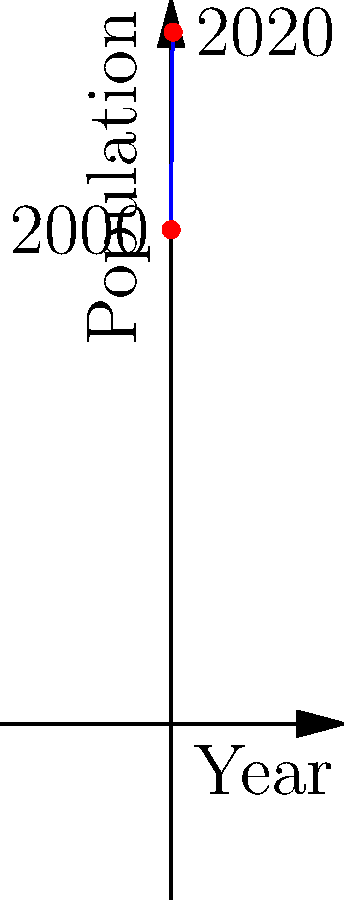The line graph shows the estimated population growth of Blahodatne from 2000 to 2020. Based on the trend shown, in which year did Blahodatne's population likely reach its peak? To determine the year when Blahodatne's population reached its peak, we need to analyze the graph:

1. The graph shows a curved line, indicating non-linear growth.
2. The population increases from 2000, reaches a maximum point, and then starts to decrease.
3. To find the year of peak population, we need to identify the highest point on the curve.
4. Visually, this highest point appears to be around the midpoint of the x-axis.
5. Since the x-axis represents years from 2000 to 2020, the midpoint would be 10 years after 2000.
6. Therefore, the population likely peaked around 2010.

This trend might reflect the economic and social changes in Blahodatne over the past two decades, showing initial growth followed by a decline, possibly due to urbanization or other demographic factors.
Answer: 2010 